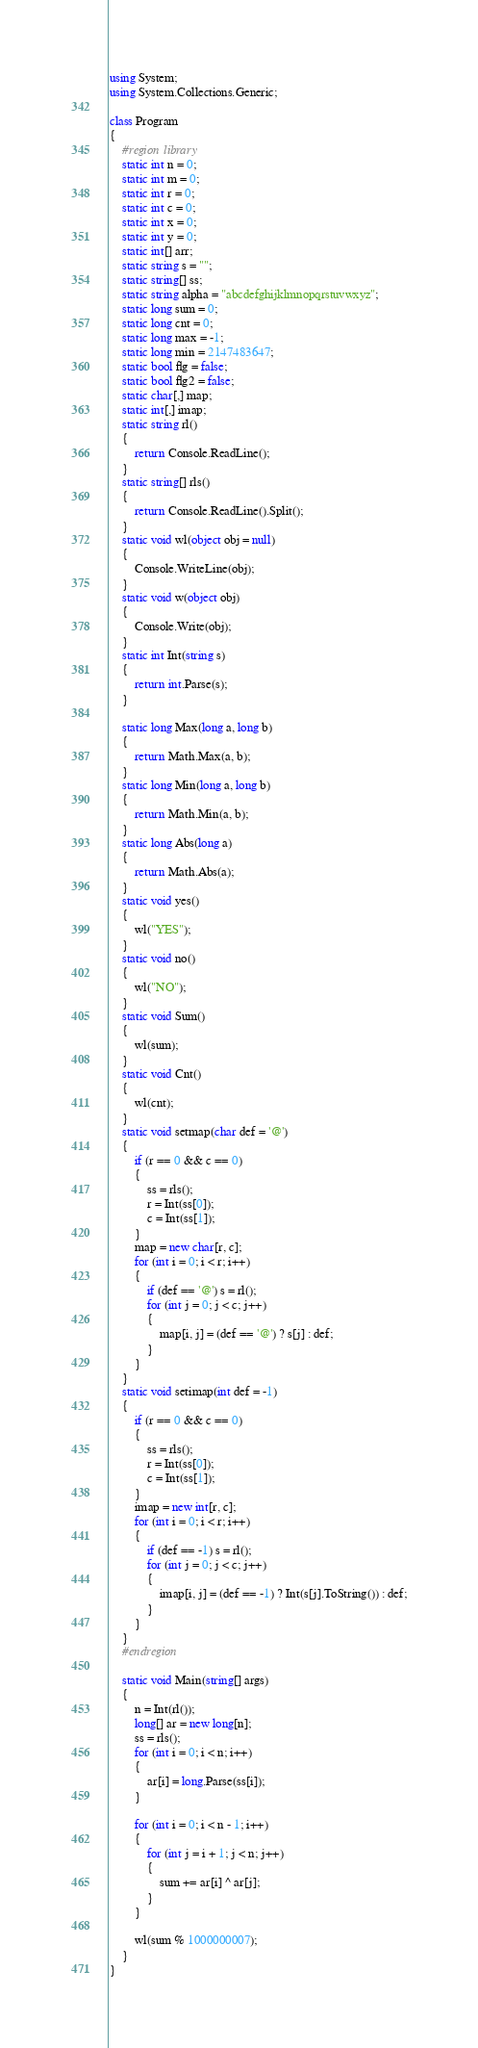Convert code to text. <code><loc_0><loc_0><loc_500><loc_500><_C#_>using System;
using System.Collections.Generic;

class Program
{
    #region library
    static int n = 0;
    static int m = 0;
    static int r = 0;
    static int c = 0;
    static int x = 0;
    static int y = 0;
    static int[] arr;
    static string s = "";
    static string[] ss;
    static string alpha = "abcdefghijklmnopqrstuvwxyz";
    static long sum = 0;
    static long cnt = 0;
    static long max = -1;
    static long min = 2147483647;
    static bool flg = false;
    static bool flg2 = false;
    static char[,] map;
    static int[,] imap;
    static string rl()
    {
        return Console.ReadLine();
    }
    static string[] rls()
    {
        return Console.ReadLine().Split();
    }
    static void wl(object obj = null)
    {
        Console.WriteLine(obj);
    }
    static void w(object obj)
    {
        Console.Write(obj);
    }
    static int Int(string s)
    {
        return int.Parse(s);
    }

    static long Max(long a, long b)
    {
        return Math.Max(a, b);
    }
    static long Min(long a, long b)
    {
        return Math.Min(a, b);
    }
    static long Abs(long a)
    {
        return Math.Abs(a);
    }
    static void yes()
    {
        wl("YES");
    }
    static void no()
    {
        wl("NO");
    }
    static void Sum()
    {
        wl(sum);
    }
    static void Cnt()
    {
        wl(cnt);
    }
    static void setmap(char def = '@')
    {
        if (r == 0 && c == 0)
        {
            ss = rls();
            r = Int(ss[0]);
            c = Int(ss[1]);
        }
        map = new char[r, c];
        for (int i = 0; i < r; i++)
        {
            if (def == '@') s = rl();
            for (int j = 0; j < c; j++)
            {
                map[i, j] = (def == '@') ? s[j] : def;
            }
        }
    }
    static void setimap(int def = -1)
    {
        if (r == 0 && c == 0)
        {
            ss = rls();
            r = Int(ss[0]);
            c = Int(ss[1]);
        }
        imap = new int[r, c];
        for (int i = 0; i < r; i++)
        {
            if (def == -1) s = rl();
            for (int j = 0; j < c; j++)
            {
                imap[i, j] = (def == -1) ? Int(s[j].ToString()) : def;
            }
        }
    }
    #endregion

    static void Main(string[] args)
    {
        n = Int(rl());
        long[] ar = new long[n];
        ss = rls();
        for (int i = 0; i < n; i++)
        {
            ar[i] = long.Parse(ss[i]);
        }

        for (int i = 0; i < n - 1; i++)
        {
            for (int j = i + 1; j < n; j++)
            {
                sum += ar[i] ^ ar[j];
            }
        }

        wl(sum % 1000000007);
    }
}

</code> 